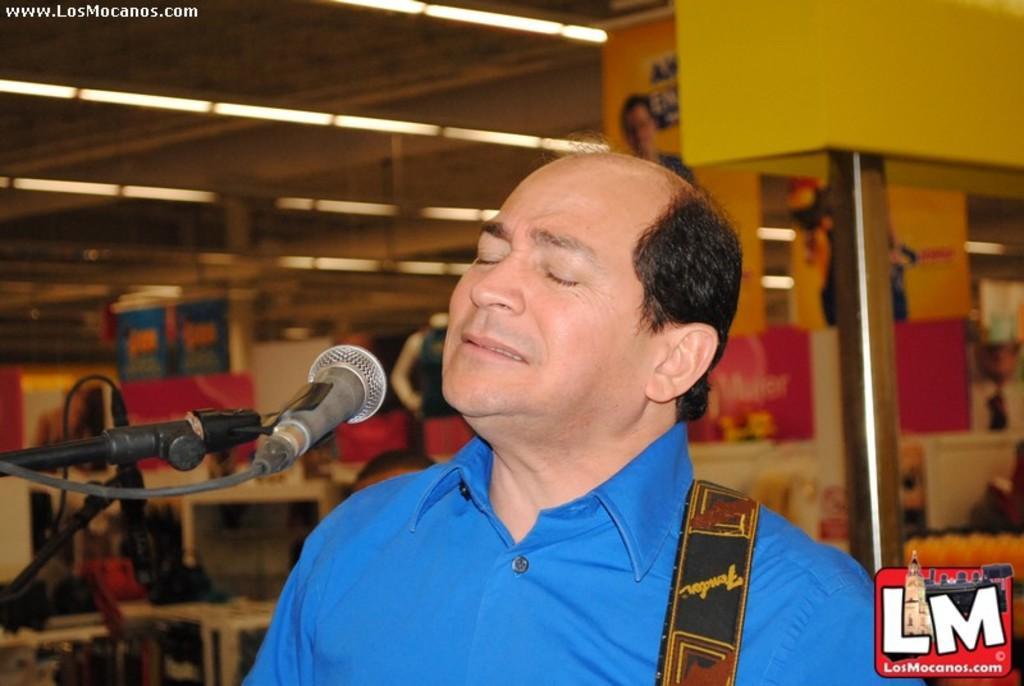How would you summarize this image in a sentence or two? This image is taken indoors. At the top of the image there is a roof and there are a few lights. In the background there are a few walls and there are a few objects and devices. There are two boards with text on them. On the left side of the image there is a mic. At the right bottom of the image there is a watermark on this image. In the middle of the image there is a man. 